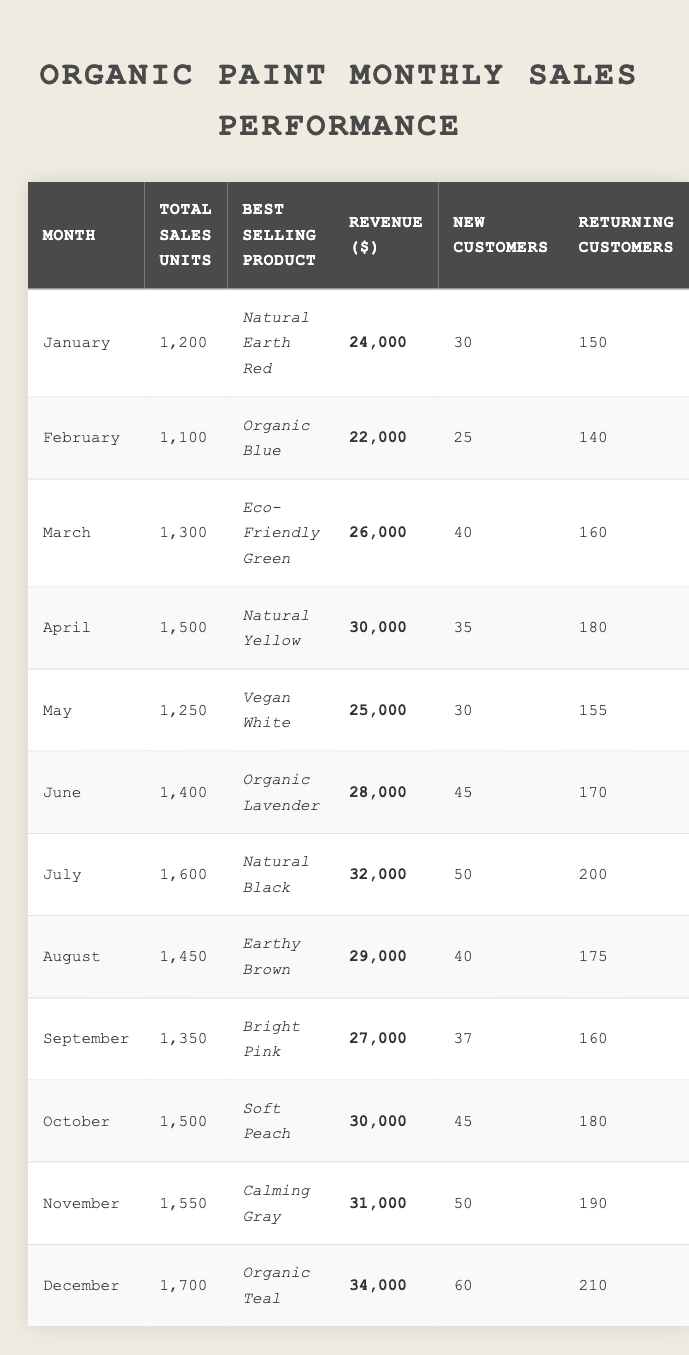What was the best-selling product in June? From the table, the row for June indicates that the best-selling product was "Organic Lavender."
Answer: Organic Lavender How many new customers were gained in October? The table shows that in October, there were 45 new customers.
Answer: 45 Which month had the highest total sales units? Looking at the total sales units for each month, July had the highest at 1600 units.
Answer: July What was the total revenue for the months of January and February combined? The revenue for January is $24,000 and for February is $22,000. Adding these gives $24,000 + $22,000 = $46,000.
Answer: $46,000 How many returning customers were there in April? The data for April shows that there were 180 returning customers.
Answer: 180 Did the total sales units in December exceed 1,600? The total sales units in December were 1,700, which is greater than 1,600.
Answer: Yes What was the average revenue from May to July? The revenues for May, June, and July are $25,000, $28,000, and $32,000 respectively. Adding them gives $25,000 + $28,000 + $32,000 = $85,000. Dividing by 3 results in an average revenue of $85,000 / 3 = $28,333.33.
Answer: $28,333.33 Which month had the highest revenue and what was it? Scanning through the table reveals that December had the highest revenue of $34,000.
Answer: $34,000 How many new customers did we gain in the months of November and December combined? November had 50 new customers and December had 60. Summing these gives 50 + 60 = 110 new customers.
Answer: 110 Find the month with the lowest total sales units. The table shows that February had the lowest total sales units at 1,100.
Answer: February Was the best-selling product in August "Earthy Brown"? Referring to the table, it indicates that the best-selling product in August was indeed "Earthy Brown."
Answer: Yes What is the difference in total sales units between July and March? The total sales units for July is 1,600 and for March it's 1,300. The difference is 1,600 - 1,300 = 300 units.
Answer: 300 Which month had the second-highest number of new customers? From the data, July had 50 new customers, and November had the same. However, December had the most with 60. Therefore, November ranks as the second-highest with 50 new customers.
Answer: November 